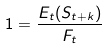Convert formula to latex. <formula><loc_0><loc_0><loc_500><loc_500>1 = \frac { E _ { t } ( S _ { t + k } ) } { F _ { t } }</formula> 